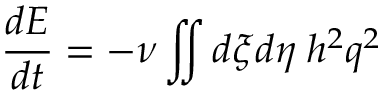<formula> <loc_0><loc_0><loc_500><loc_500>\frac { d E } { d t } = - \nu \iint d \xi d \eta \, h ^ { 2 } q ^ { 2 }</formula> 